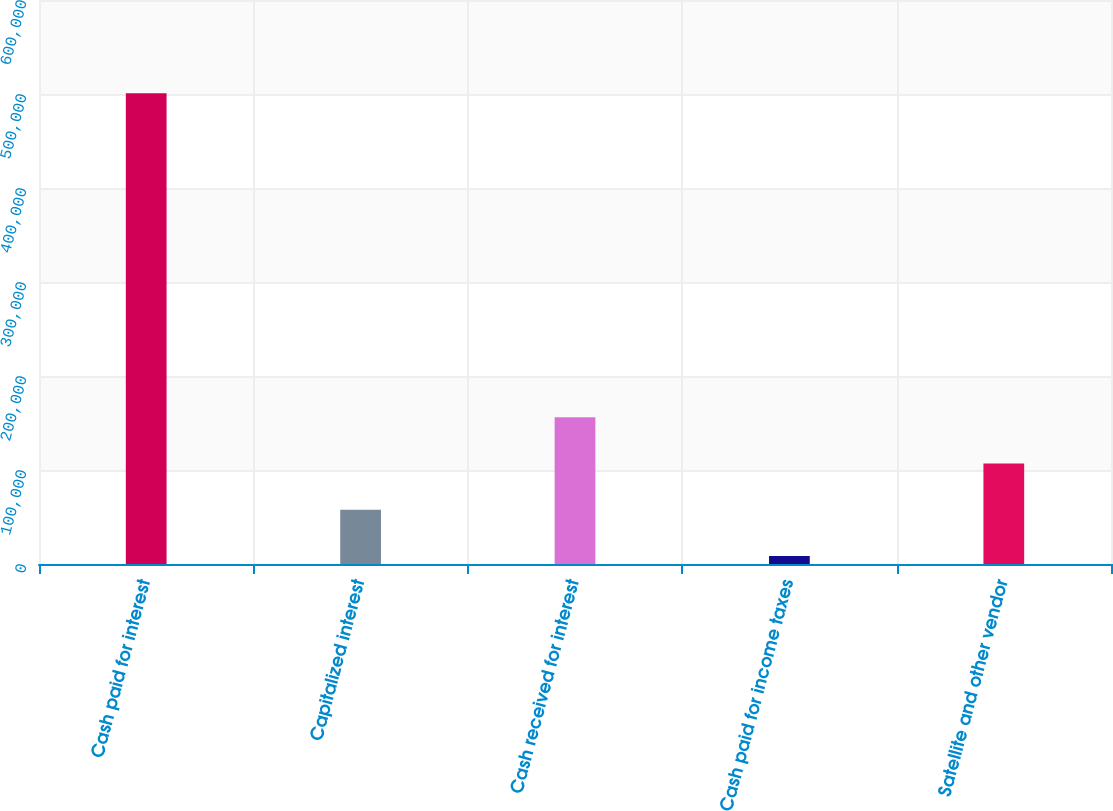Convert chart. <chart><loc_0><loc_0><loc_500><loc_500><bar_chart><fcel>Cash paid for interest<fcel>Capitalized interest<fcel>Cash received for interest<fcel>Cash paid for income taxes<fcel>Satellite and other vendor<nl><fcel>500879<fcel>57644.3<fcel>156141<fcel>8396<fcel>106893<nl></chart> 